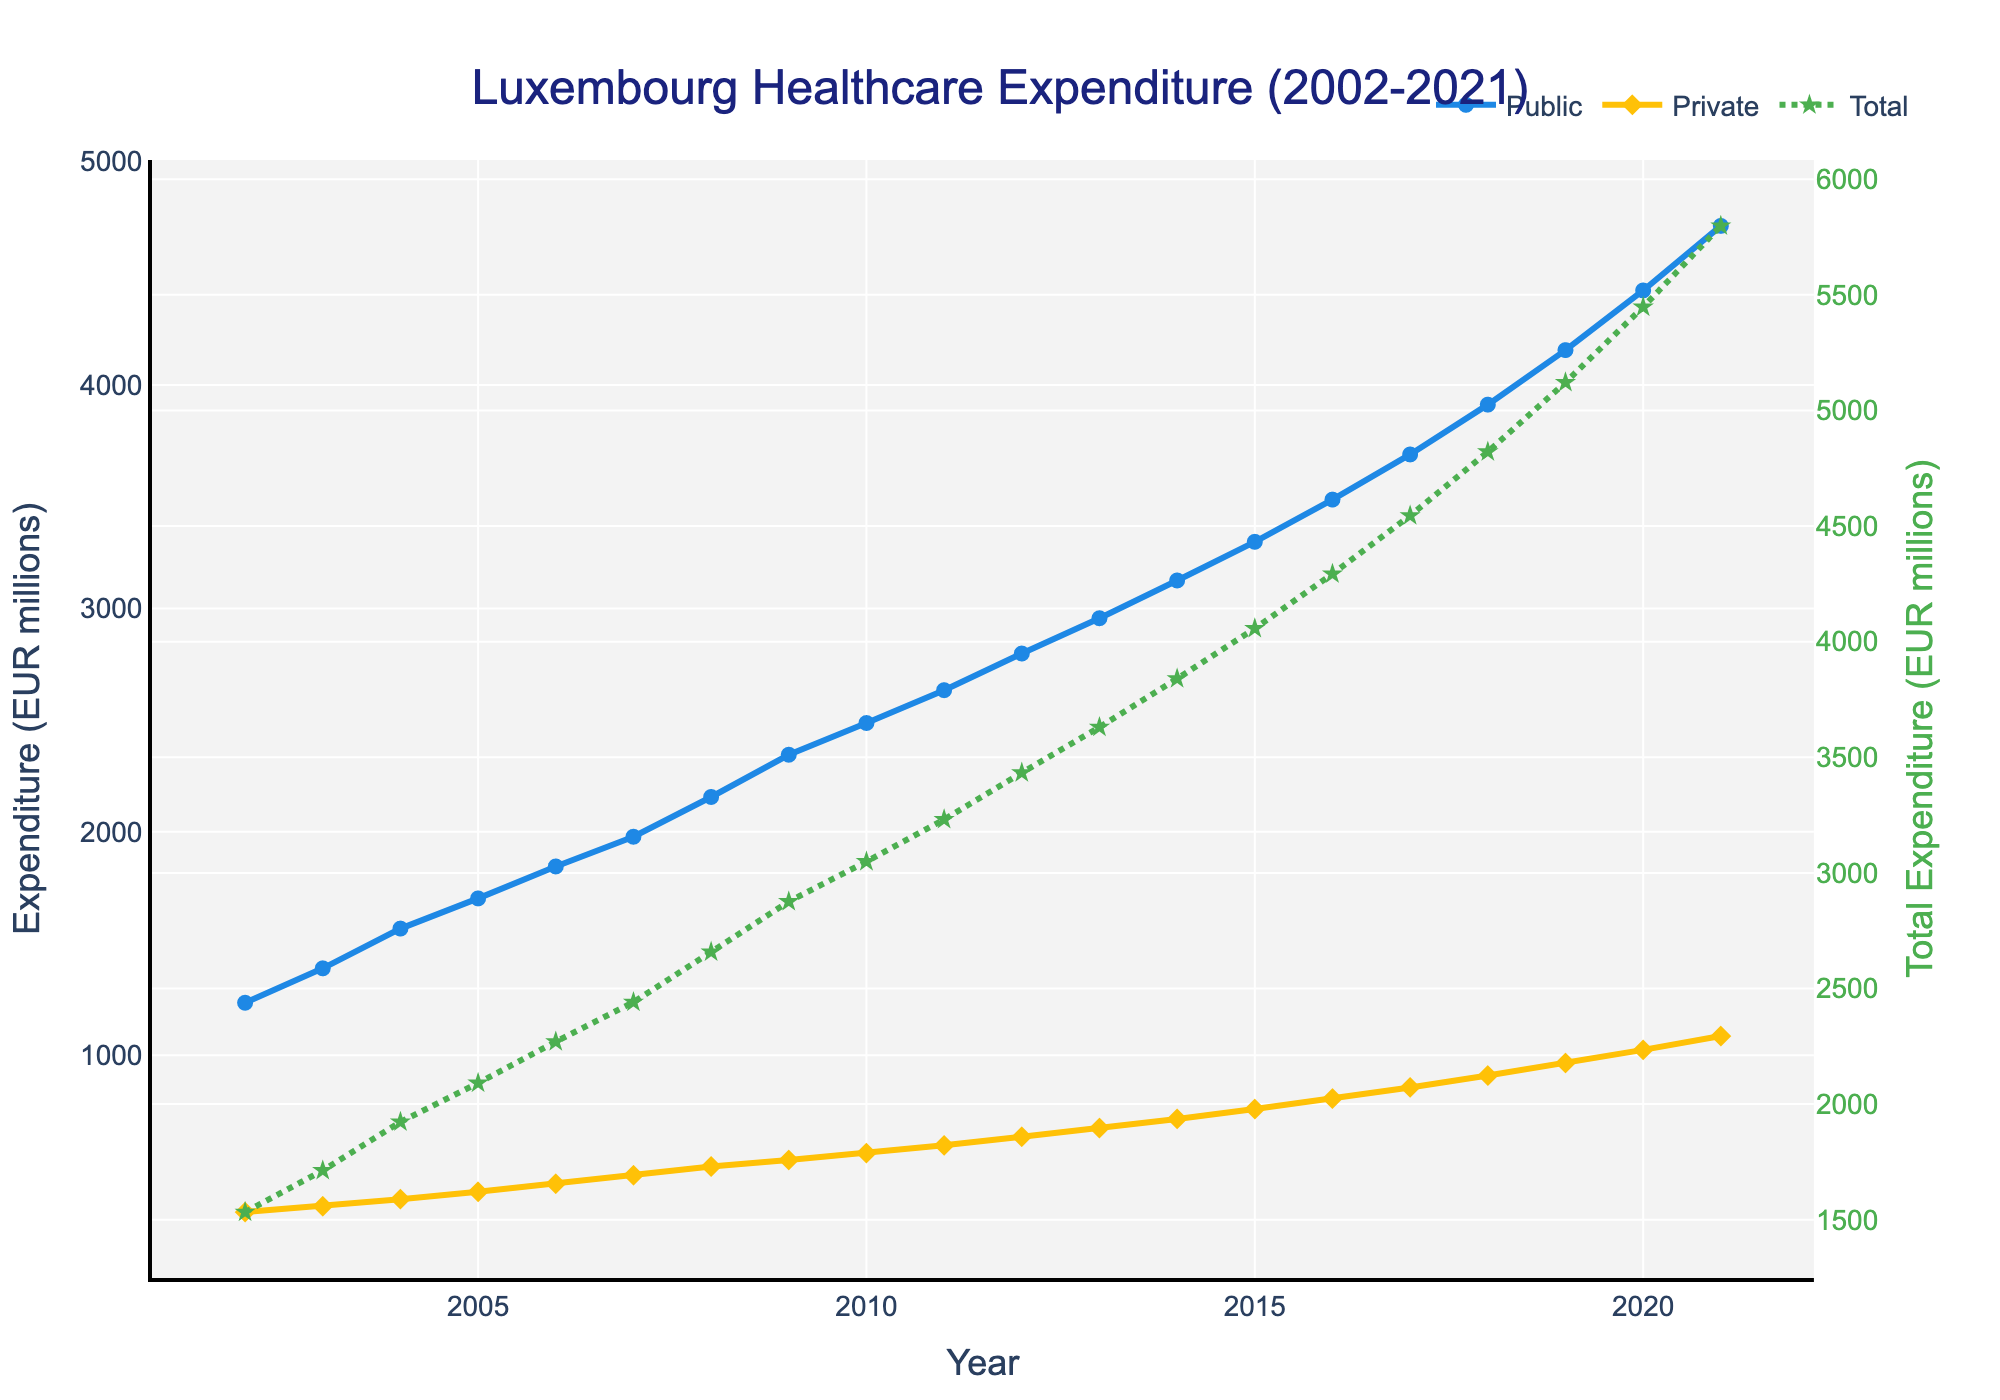What's the overall trend of public healthcare expenditure from 2002 to 2021? The public healthcare expenditure shows a consistent increase over the 20-year period, starting at 1235 million EUR in 2002 and reaching 4712 million EUR in 2021. This upward trend indicates a growing investment in public healthcare.
Answer: Consistent increase How has private healthcare expenditure changed from 2002 to 2021? Private healthcare expenditure has also shown a gradual increase over the 20-year period, starting at 298 million EUR in 2002 and reaching 1086 million EUR in 2021. This indicates rising spending in the private sector as well.
Answer: Gradual increase Which year saw the highest increase in total healthcare expenditure compared to the previous year? By examining the steepness of the line representing total expenditure, the year 2020 shows the highest increase, with total healthcare expenditure rising from 5086 million EUR in 2019 to 5547 million EUR in 2020. This is a difference of 461 million EUR, the largest in any single year.
Answer: 2020 Compare the growth rates of public and private healthcare expenditures between 2002 and 2021. Which grew faster? To compare the growth rates, calculate the percentages:
Public: ((4712 - 1235) / 1235) * 100 = 281.5%
Private: ((1086 - 298) / 298) * 100 = 264.1%
Thus, public healthcare expenditure grew faster than private healthcare expenditure over the period.
Answer: Public grew faster In which year did the sum of public and private healthcare expenditure first exceed 5000 million EUR? We need to find the year where the total expenditure first goes over 5000 million EUR. Looking at the data, this happens in 2019 when the total spending reaches 5121 million EUR.
Answer: 2019 Which year had the higher expenditure on public healthcare compared to private healthcare? By comparing the values in each year, we see that every single year from 2002 to 2021 has higher public healthcare expenditure than private healthcare expenditure. So, the answer is every year from 2002 to 2021.
Answer: Every year What is the visual difference in line styles between total and the other expenditures? The line for total healthcare expenditure is shown as a green, dotted line with star markers, whereas the lines for public and private expenditures are solid lines in blue and orange with circle and diamond markers, respectively.
Answer: Dotted green line with star markers By how much did public healthcare expenditure increase from 2006 to 2016? Public healthcare expenditure in 2006 was 1845 million EUR and in 2016 was 3487 million EUR. The increase can be calculated as:
3487 - 1845 = 1642 million EUR.
Answer: 1642 million EUR What was the average annual increase in private healthcare expenditure over the 20-year period? Calculate the difference in private expenditure between 2021 and 2002, then divide by the number of years:
(1086 - 298) / 20 = 39.4 million EUR per year (on average).
Answer: 39.4 million EUR per year Which sector (public or private) had more consistent growth across the years? By looking at the smoothness of the respective lines across the years, the public sector shows more consistent and linear growth, whereas the private sector shows growth but with some fluctuations.
Answer: Public sector 